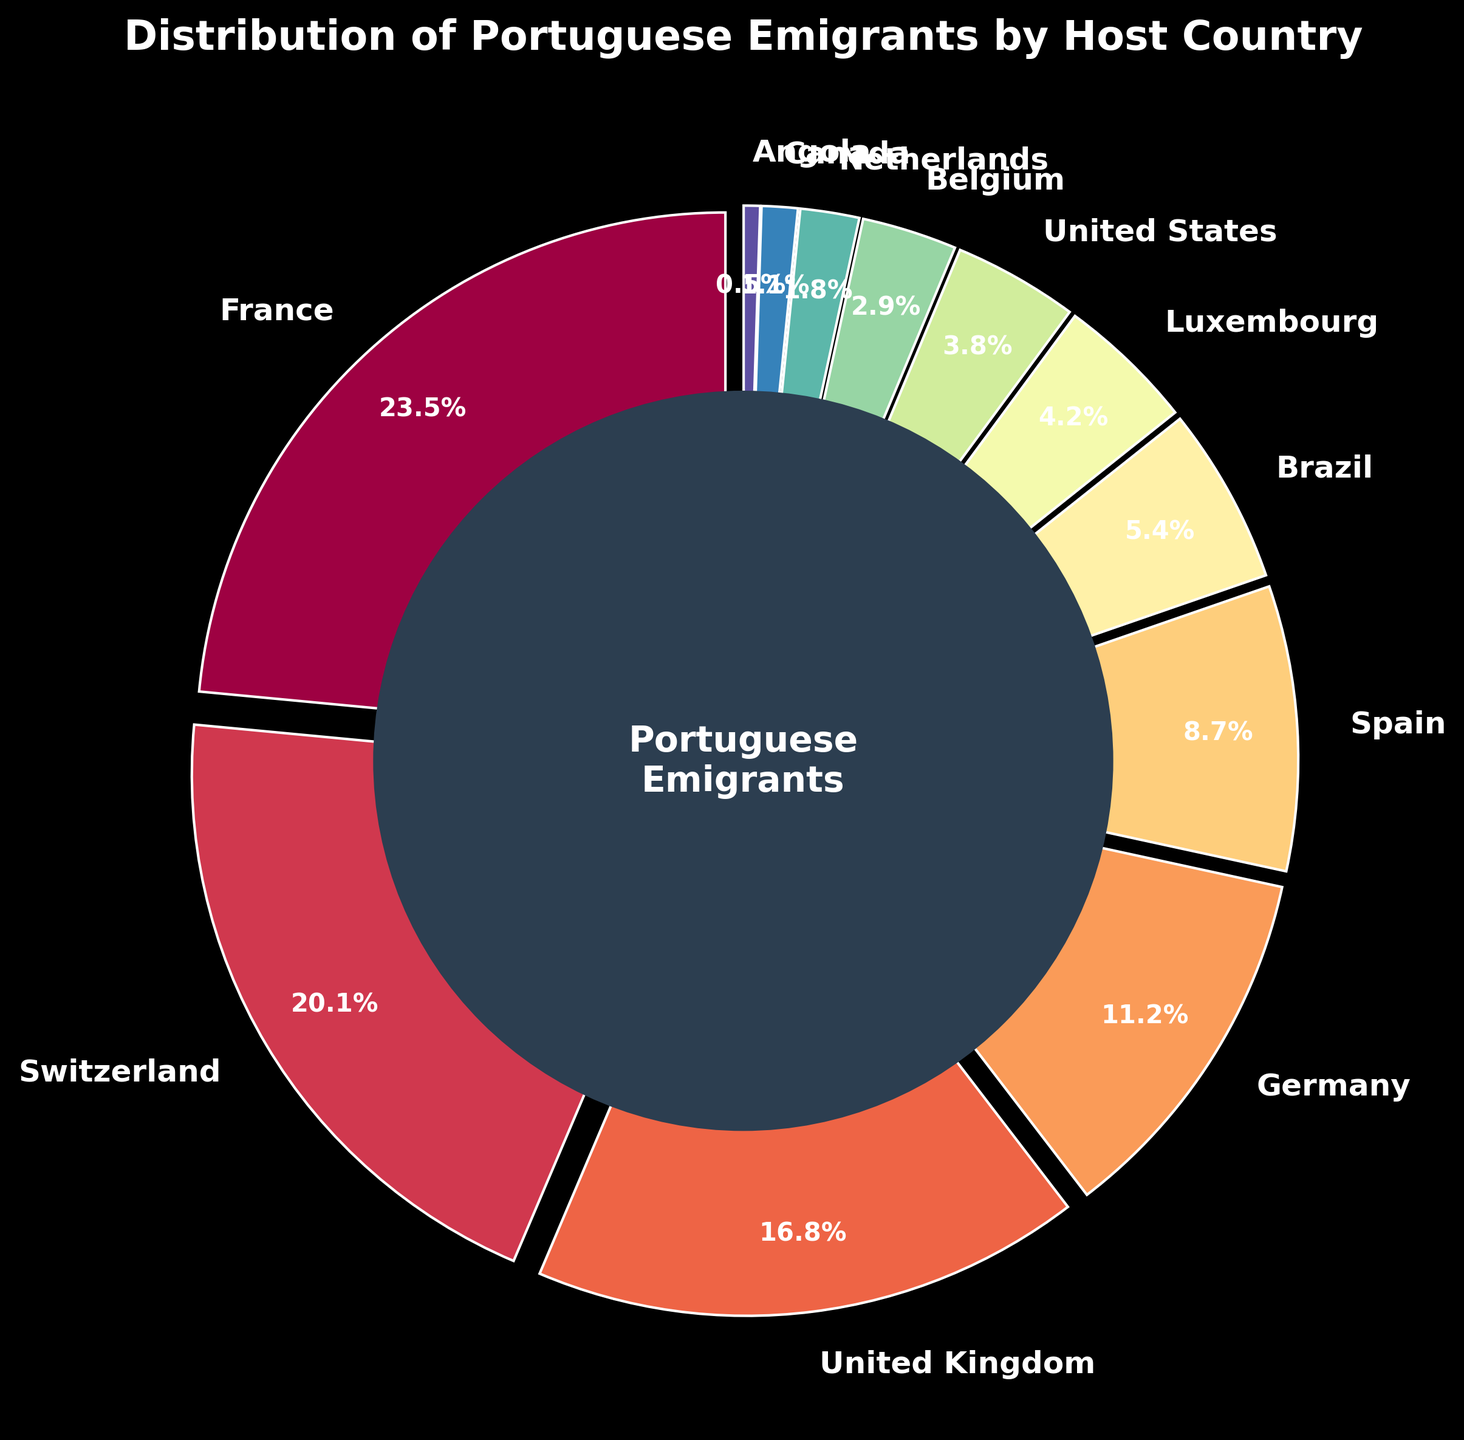Which country has the highest percentage of Portuguese emigrants? From the pie chart, the largest segment corresponds to France.
Answer: France Which country has fewer Portuguese emigrants: Spain or Brazil? By comparing the segments, Spain has 8.7% and Brazil has 5.4%.
Answer: Brazil What is the sum of the percentages of Portuguese emigrants in France and Switzerland? France has 23.5% and Switzerland has 20.1%. Summing them up, 23.5 + 20.1 = 43.6%.
Answer: 43.6% Are the combined emigrants in Germany and Spain greater than those in the United Kingdom? Germany has 11.2% and Spain has 8.7%. Combined, it's 11.2 + 8.7 = 19.9%. The United Kingdom has 16.8%, so 19.9% is greater than 16.8%.
Answer: Yes Which country has less than 1% of Portuguese emigrants? From the chart, Angola has 0.5%.
Answer: Angola What is the total percentage of Portuguese emigrants in Canada and the United States? Canada has 1.1% and the United States has 3.8%. Adding them together, 1.1 + 3.8 = 4.9%.
Answer: 4.9% Which country has a segment with a noticeably different color compared to the others? The pie chart uses colors from the Spectral colormap, with each country being a unique color. The center circle is dark blue and the segments have a gradual color transition.
Answer: Center circle (as it’s filled differently) Is the percentage of Portuguese emigrants in Brazil smaller than that in Luxembourg? Brazil has 5.4% and Luxembourg has 4.2%. So, 5.4% is greater than 4.2%.
Answer: No By how much does the percentage of Portuguese emigrants in the United Kingdom exceed that in Belgium? The United Kingdom has 16.8% and Belgium has 2.9%. The difference is 16.8 - 2.9 = 13.9%.
Answer: 13.9% What percentage of Portuguese emigrants are in countries with >10% each? France (23.5%), Switzerland (20.1%), United Kingdom (16.8%), and Germany (11.2%) are >10%. Summing these, 23.5 + 20.1 + 16.8 + 11.2 = 71.6%.
Answer: 71.6% 